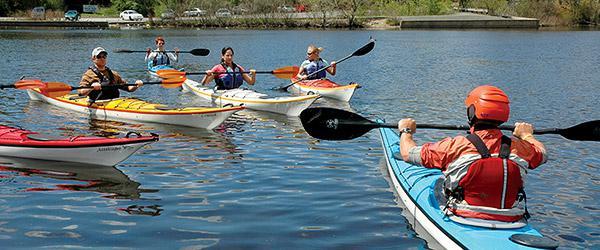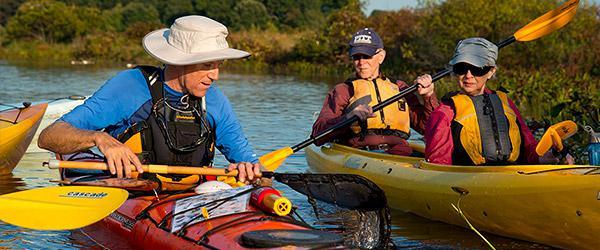The first image is the image on the left, the second image is the image on the right. Assess this claim about the two images: "In the image on the right, four people are riding in one canoe.". Correct or not? Answer yes or no. No. The first image is the image on the left, the second image is the image on the right. For the images displayed, is the sentence "The left image includes a canoe in the foreground heading away from the camera, and the right image shows at least one forward moving kayak-type boat." factually correct? Answer yes or no. Yes. 